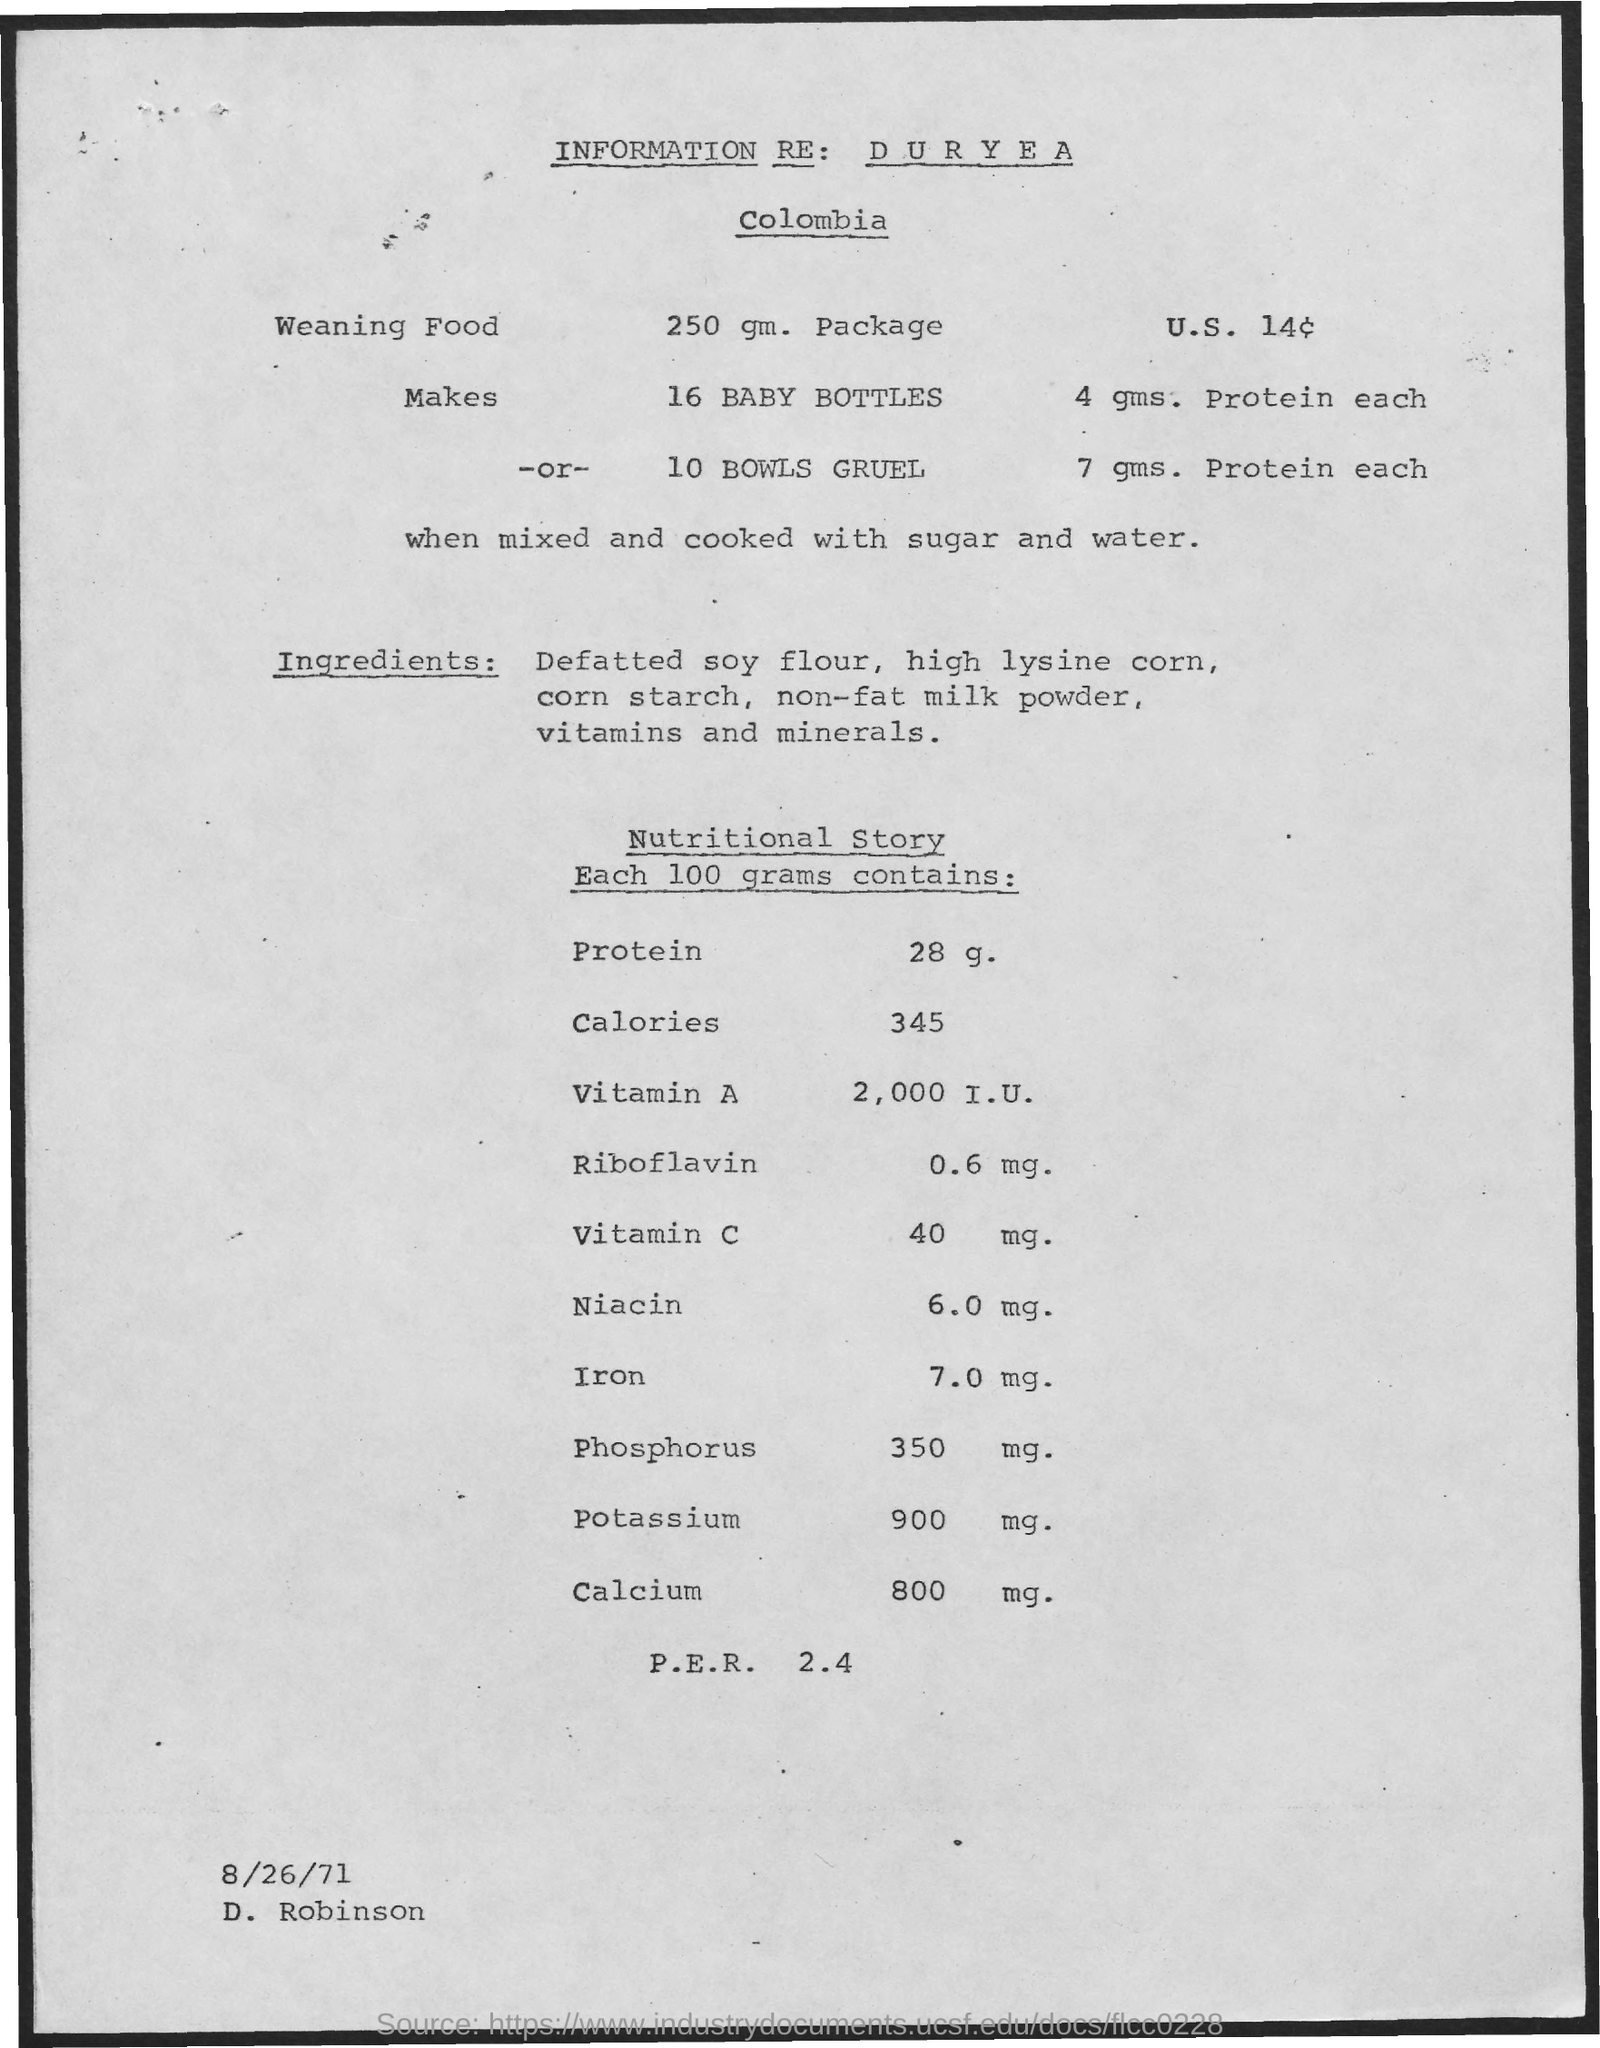What is the date mentioned ?
Offer a terse response. 8/26/71. What is the name of the person mentioned ?
Your response must be concise. D. Robinson. 